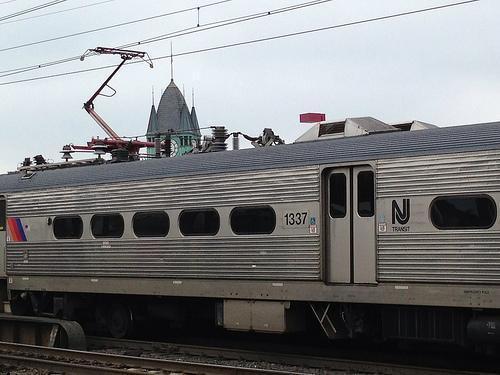How many windows are there?
Give a very brief answer. 8. How many doors are there?
Give a very brief answer. 2. 